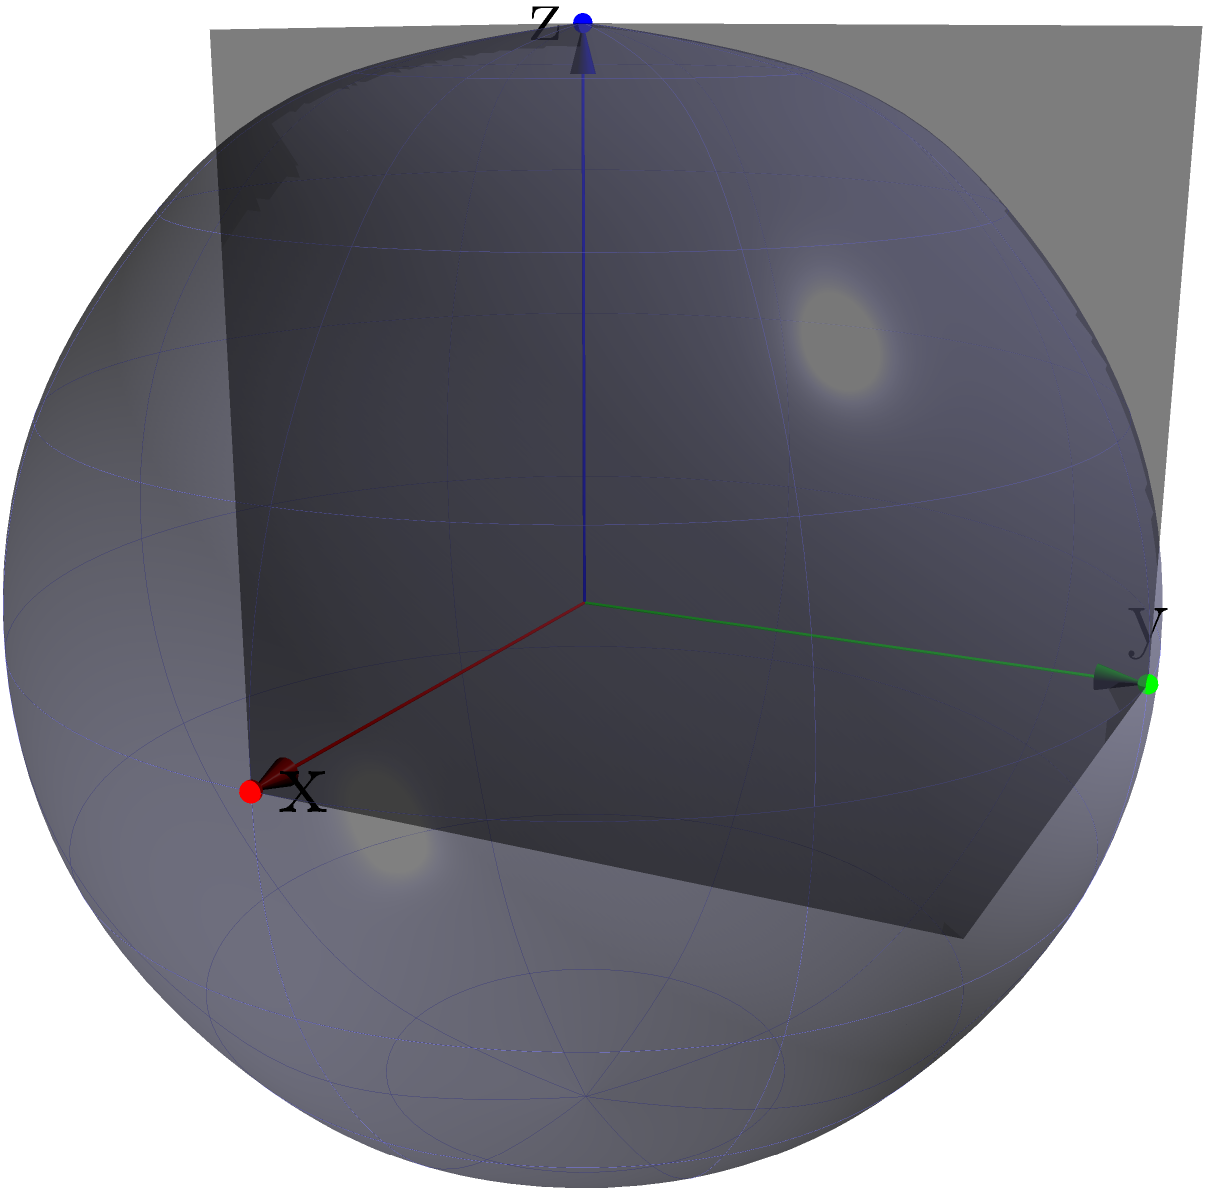Consider a spherical spacecraft design with a rotation group isomorphic to $SO(3)$. If a new material coating requires the craft to undergo a series of rotations $R_x(\frac{\pi}{2})$, $R_y(\frac{\pi}{3})$, and $R_z(\frac{\pi}{4})$ in that order, what is the resulting rotation matrix? To solve this problem, we need to follow these steps:

1) First, recall that the rotation matrices for rotations around x, y, and z axes are:

   $R_x(\theta) = \begin{pmatrix}
   1 & 0 & 0 \\
   0 & \cos\theta & -\sin\theta \\
   0 & \sin\theta & \cos\theta
   \end{pmatrix}$

   $R_y(\theta) = \begin{pmatrix}
   \cos\theta & 0 & \sin\theta \\
   0 & 1 & 0 \\
   -\sin\theta & 0 & \cos\theta
   \end{pmatrix}$

   $R_z(\theta) = \begin{pmatrix}
   \cos\theta & -\sin\theta & 0 \\
   \sin\theta & \cos\theta & 0 \\
   0 & 0 & 1
   \end{pmatrix}$

2) We need to apply these rotations in the order given: first $R_x(\frac{\pi}{2})$, then $R_y(\frac{\pi}{3})$, and finally $R_z(\frac{\pi}{4})$.

3) The resulting rotation matrix will be the product of these three matrices in reverse order:

   $R = R_z(\frac{\pi}{4}) \cdot R_y(\frac{\pi}{3}) \cdot R_x(\frac{\pi}{2})$

4) Let's calculate each matrix:

   $R_x(\frac{\pi}{2}) = \begin{pmatrix}
   1 & 0 & 0 \\
   0 & 0 & -1 \\
   0 & 1 & 0
   \end{pmatrix}$

   $R_y(\frac{\pi}{3}) = \begin{pmatrix}
   \frac{\sqrt{3}}{2} & 0 & \frac{1}{2} \\
   0 & 1 & 0 \\
   -\frac{1}{2} & 0 & \frac{\sqrt{3}}{2}
   \end{pmatrix}$

   $R_z(\frac{\pi}{4}) = \begin{pmatrix}
   \frac{\sqrt{2}}{2} & -\frac{\sqrt{2}}{2} & 0 \\
   \frac{\sqrt{2}}{2} & \frac{\sqrt{2}}{2} & 0 \\
   0 & 0 & 1
   \end{pmatrix}$

5) Now, we multiply these matrices in the correct order:

   $R = R_z(\frac{\pi}{4}) \cdot R_y(\frac{\pi}{3}) \cdot R_x(\frac{\pi}{2})$

6) After performing the matrix multiplication, we get:

   $R = \begin{pmatrix}
   \frac{\sqrt{6}}{4} & -\frac{\sqrt{2}}{2} & \frac{\sqrt{3}}{2} \\
   \frac{\sqrt{6}}{4} & \frac{\sqrt{2}}{2} & -\frac{1}{2} \\
   -\frac{\sqrt{2}}{2} & 0 & \frac{\sqrt{3}}{2}
   \end{pmatrix}$

This is the resulting rotation matrix.
Answer: $\begin{pmatrix}
\frac{\sqrt{6}}{4} & -\frac{\sqrt{2}}{2} & \frac{\sqrt{3}}{2} \\
\frac{\sqrt{6}}{4} & \frac{\sqrt{2}}{2} & -\frac{1}{2} \\
-\frac{\sqrt{2}}{2} & 0 & \frac{\sqrt{3}}{2}
\end{pmatrix}$ 